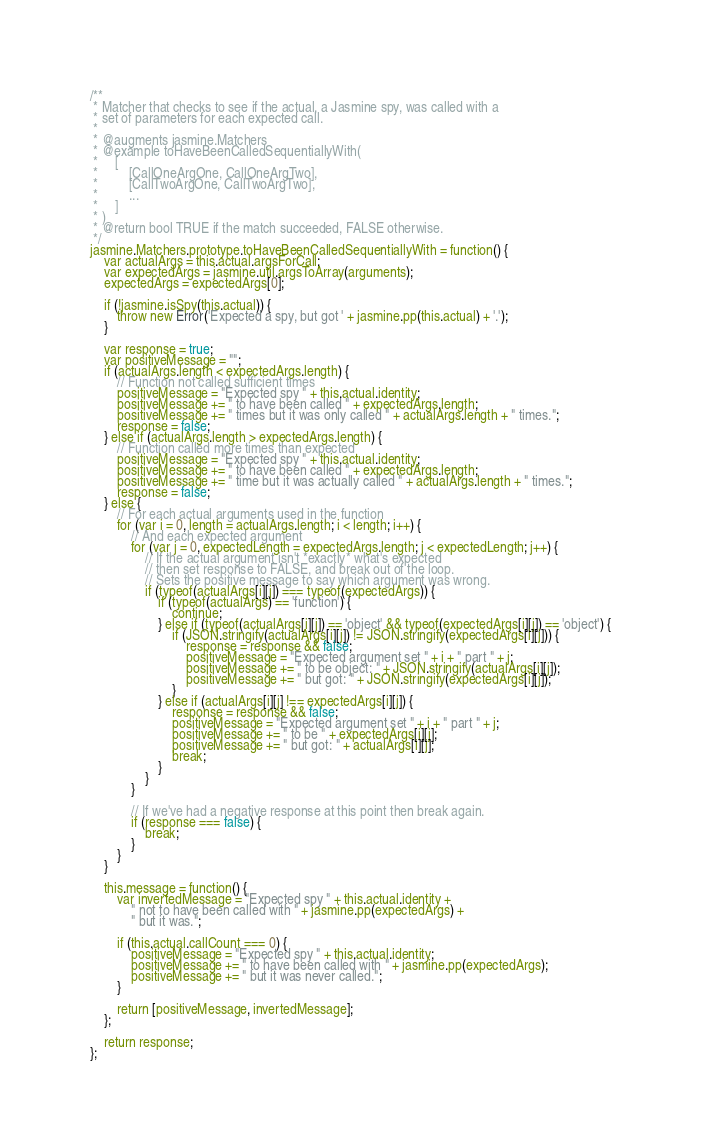<code> <loc_0><loc_0><loc_500><loc_500><_JavaScript_>/**
 * Matcher that checks to see if the actual, a Jasmine spy, was called with a
 * set of parameters for each expected call.
 *
 * @augments jasmine.Matchers
 * @example toHaveBeenCalledSequentiallyWith(
 *     [
 *         [CallOneArgOne, CallOneArgTwo],
 *         [CallTwoArgOne, CallTwoArgTwo],
 *         ...
 *     ]
 * )
 * @return bool TRUE if the match succeeded, FALSE otherwise.
 */
jasmine.Matchers.prototype.toHaveBeenCalledSequentiallyWith = function() {
    var actualArgs = this.actual.argsForCall;
    var expectedArgs = jasmine.util.argsToArray(arguments);
    expectedArgs = expectedArgs[0];

    if (!jasmine.isSpy(this.actual)) {
        throw new Error('Expected a spy, but got ' + jasmine.pp(this.actual) + '.');
    }

    var response = true;
    var positiveMessage = "";
    if (actualArgs.length < expectedArgs.length) {
        // Function not called sufficient times
        positiveMessage = "Expected spy " + this.actual.identity;
        positiveMessage += " to have been called " + expectedArgs.length;
        positiveMessage += " times but it was only called " + actualArgs.length + " times.";
        response = false;
    } else if (actualArgs.length > expectedArgs.length) {
        // Function called more times than expected
        positiveMessage = "Expected spy " + this.actual.identity;
        positiveMessage += " to have been called " + expectedArgs.length;
        positiveMessage += " time but it was actually called " + actualArgs.length + " times.";
        response = false;
    } else {
        // For each actual arguments used in the function
        for (var i = 0, length = actualArgs.length; i < length; i++) {
            // And each expected argument
            for (var j = 0, expectedLength = expectedArgs.length; j < expectedLength; j++) {
                // If the actual argument isn't *exactly* what's expected
                // then set response to FALSE, and break out of the loop.
                // Sets the positive message to say which argument was wrong.
                if (typeof(actualArgs[i][j]) === typeof(expectedArgs)) {
                    if (typeof(actualArgs) == 'function') {
                        continue;
                    } else if (typeof(actualArgs[i][j]) == 'object' && typeof(expectedArgs[i][j]) == 'object') {
                        if (JSON.stringify(actualArgs[i][j]) != JSON.stringify(expectedArgs[i][j])) {
                            response = response && false;
                            positiveMessage = "Expected argument set " + i + " part " + j;
                            positiveMessage += " to be object: " + JSON.stringify(actualArgs[i][j]);
                            positiveMessage += " but got: " + JSON.stringify(expectedArgs[i][j]);
                        }
                    } else if (actualArgs[i][j] !== expectedArgs[i][j]) {
                        response = response && false;
                        positiveMessage = "Expected argument set " + i + " part " + j;
                        positiveMessage += " to be " + expectedArgs[i][j];
                        positiveMessage += " but got: " + actualArgs[i][j];
                        break;
                    }
                }
            }

            // If we've had a negative response at this point then break again.
            if (response === false) {
                break;
            }
        }
    }

    this.message = function() {
        var invertedMessage = "Expected spy " + this.actual.identity +
            " not to have been called with " + jasmine.pp(expectedArgs) +
            " but it was.";

        if (this.actual.callCount === 0) {
            positiveMessage = "Expected spy " + this.actual.identity;
            positiveMessage += " to have been called with " + jasmine.pp(expectedArgs);
            positiveMessage += " but it was never called.";
        }

        return [positiveMessage, invertedMessage];
    };

    return response;
};</code> 